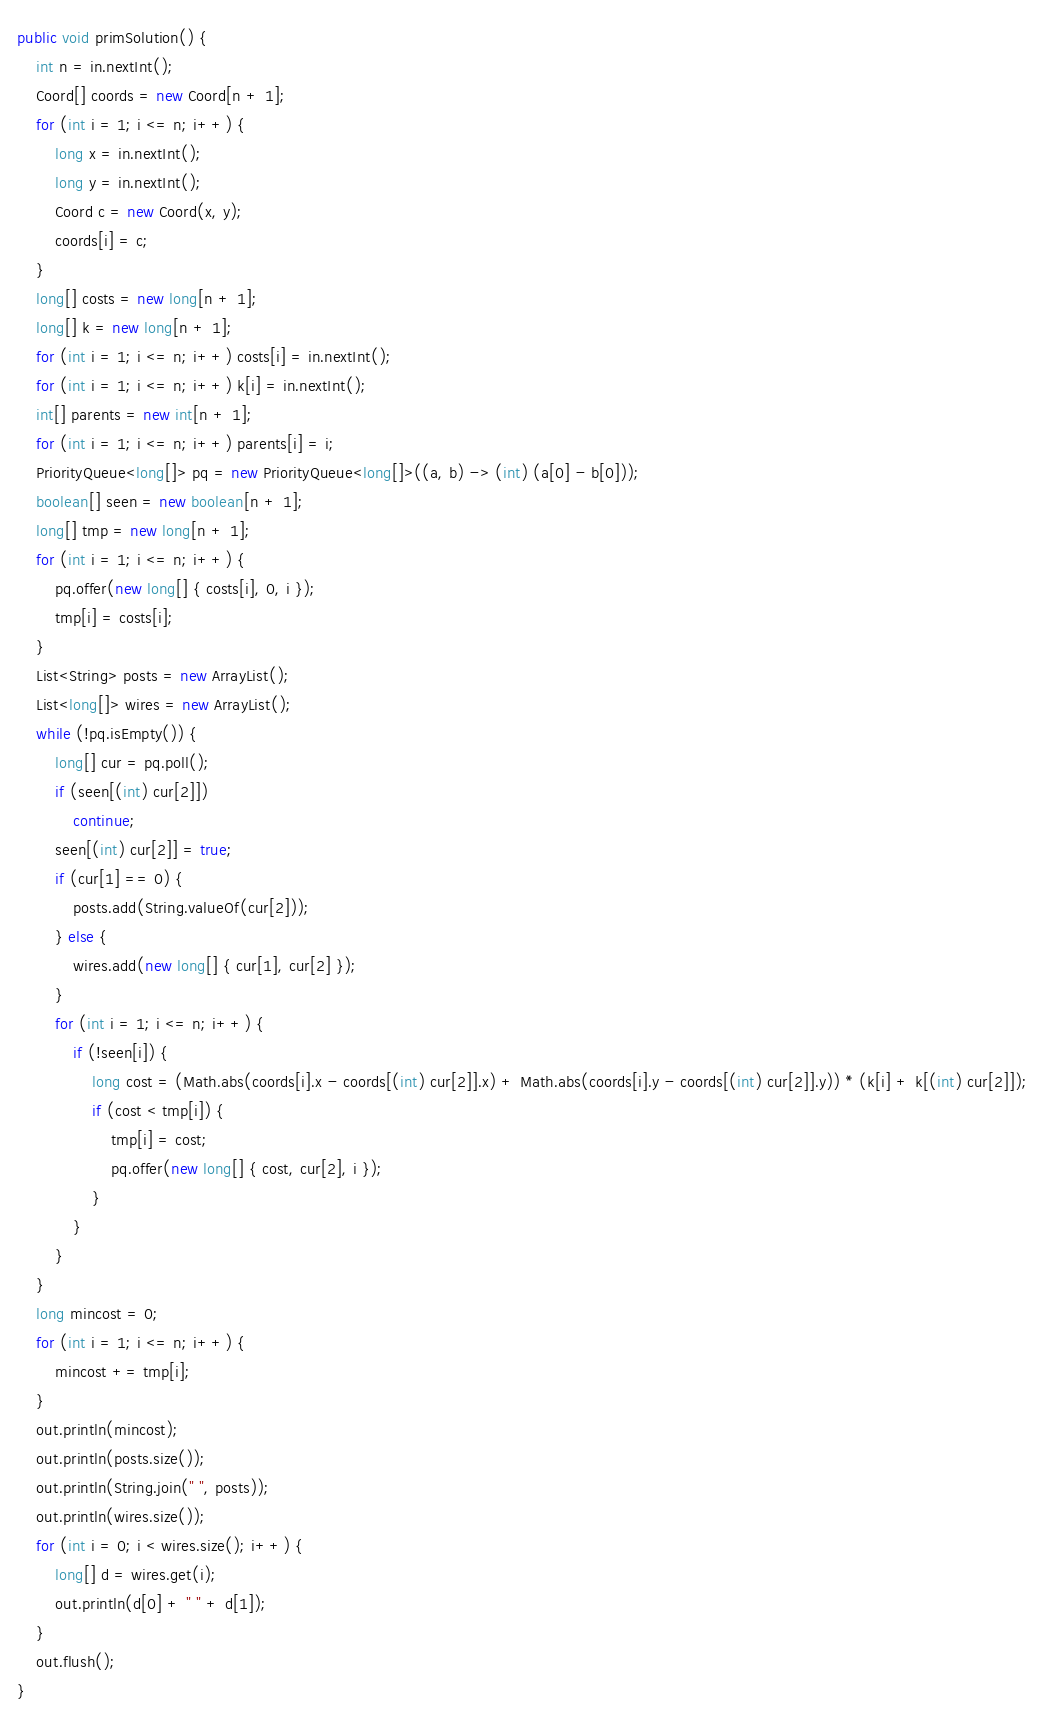<code> <loc_0><loc_0><loc_500><loc_500><_Java_>public void primSolution() {
    int n = in.nextInt();
    Coord[] coords = new Coord[n + 1];
    for (int i = 1; i <= n; i++) {
        long x = in.nextInt();
        long y = in.nextInt();
        Coord c = new Coord(x, y);
        coords[i] = c;
    }
    long[] costs = new long[n + 1];
    long[] k = new long[n + 1];
    for (int i = 1; i <= n; i++) costs[i] = in.nextInt();
    for (int i = 1; i <= n; i++) k[i] = in.nextInt();
    int[] parents = new int[n + 1];
    for (int i = 1; i <= n; i++) parents[i] = i;
    PriorityQueue<long[]> pq = new PriorityQueue<long[]>((a, b) -> (int) (a[0] - b[0]));
    boolean[] seen = new boolean[n + 1];
    long[] tmp = new long[n + 1];
    for (int i = 1; i <= n; i++) {
        pq.offer(new long[] { costs[i], 0, i });
        tmp[i] = costs[i];
    }
    List<String> posts = new ArrayList();
    List<long[]> wires = new ArrayList();
    while (!pq.isEmpty()) {
        long[] cur = pq.poll();
        if (seen[(int) cur[2]])
            continue;
        seen[(int) cur[2]] = true;
        if (cur[1] == 0) {
            posts.add(String.valueOf(cur[2]));
        } else {
            wires.add(new long[] { cur[1], cur[2] });
        }
        for (int i = 1; i <= n; i++) {
            if (!seen[i]) {
                long cost = (Math.abs(coords[i].x - coords[(int) cur[2]].x) + Math.abs(coords[i].y - coords[(int) cur[2]].y)) * (k[i] + k[(int) cur[2]]);
                if (cost < tmp[i]) {
                    tmp[i] = cost;
                    pq.offer(new long[] { cost, cur[2], i });
                }
            }
        }
    }
    long mincost = 0;
    for (int i = 1; i <= n; i++) {
        mincost += tmp[i];
    }
    out.println(mincost);
    out.println(posts.size());
    out.println(String.join(" ", posts));
    out.println(wires.size());
    for (int i = 0; i < wires.size(); i++) {
        long[] d = wires.get(i);
        out.println(d[0] + " " + d[1]);
    }
    out.flush();
}</code> 